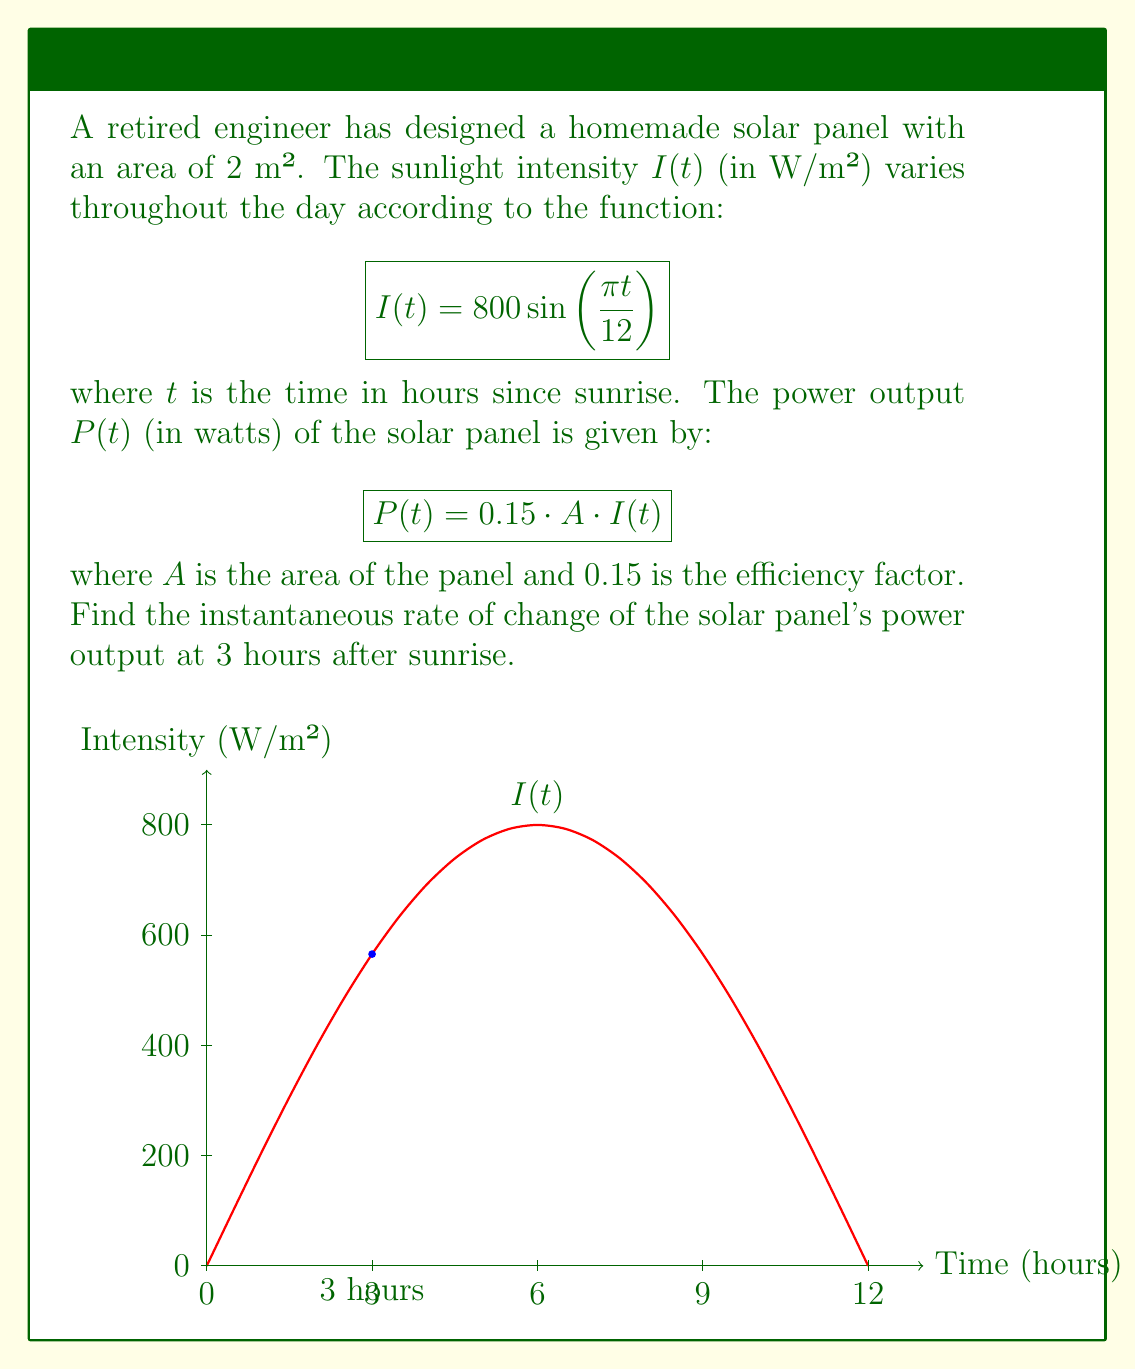Can you solve this math problem? To find the instantaneous rate of change of the solar panel's power output, we need to calculate the derivative of $P(t)$ with respect to $t$ and evaluate it at $t=3$. Let's approach this step-by-step:

1) First, let's express $P(t)$ in terms of $t$:
   $$P(t) = 0.15 \cdot A \cdot I(t)$$
   $$P(t) = 0.15 \cdot 2 \cdot 800 \sin\left(\frac{\pi t}{12}\right)$$
   $$P(t) = 240 \sin\left(\frac{\pi t}{12}\right)$$

2) Now, we need to find $\frac{dP}{dt}$:
   $$\frac{dP}{dt} = 240 \cdot \frac{d}{dt}\left[\sin\left(\frac{\pi t}{12}\right)\right]$$
   
   Using the chain rule:
   $$\frac{dP}{dt} = 240 \cdot \cos\left(\frac{\pi t}{12}\right) \cdot \frac{\pi}{12}$$
   
   $$\frac{dP}{dt} = 20\pi \cos\left(\frac{\pi t}{12}\right)$$

3) Now, we evaluate this at $t=3$:
   $$\left.\frac{dP}{dt}\right|_{t=3} = 20\pi \cos\left(\frac{\pi \cdot 3}{12}\right)$$
   $$= 20\pi \cos\left(\frac{\pi}{4}\right)$$
   $$= 20\pi \cdot \frac{\sqrt{2}}{2}$$
   $$= 10\pi\sqrt{2} \approx 44.43$$

This result represents the instantaneous rate of change of the solar panel's power output at 3 hours after sunrise, measured in watts per hour (W/h).
Answer: $10\pi\sqrt{2}$ W/h 